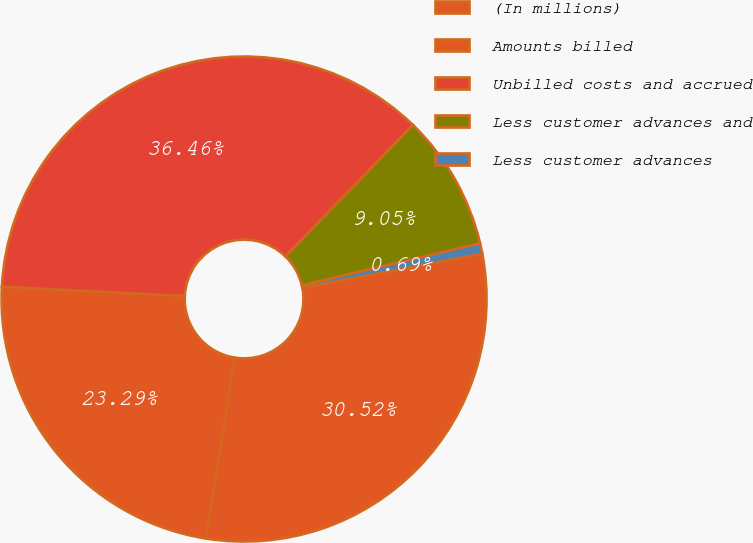Convert chart to OTSL. <chart><loc_0><loc_0><loc_500><loc_500><pie_chart><fcel>(In millions)<fcel>Amounts billed<fcel>Unbilled costs and accrued<fcel>Less customer advances and<fcel>Less customer advances<nl><fcel>30.52%<fcel>23.29%<fcel>36.46%<fcel>9.05%<fcel>0.69%<nl></chart> 